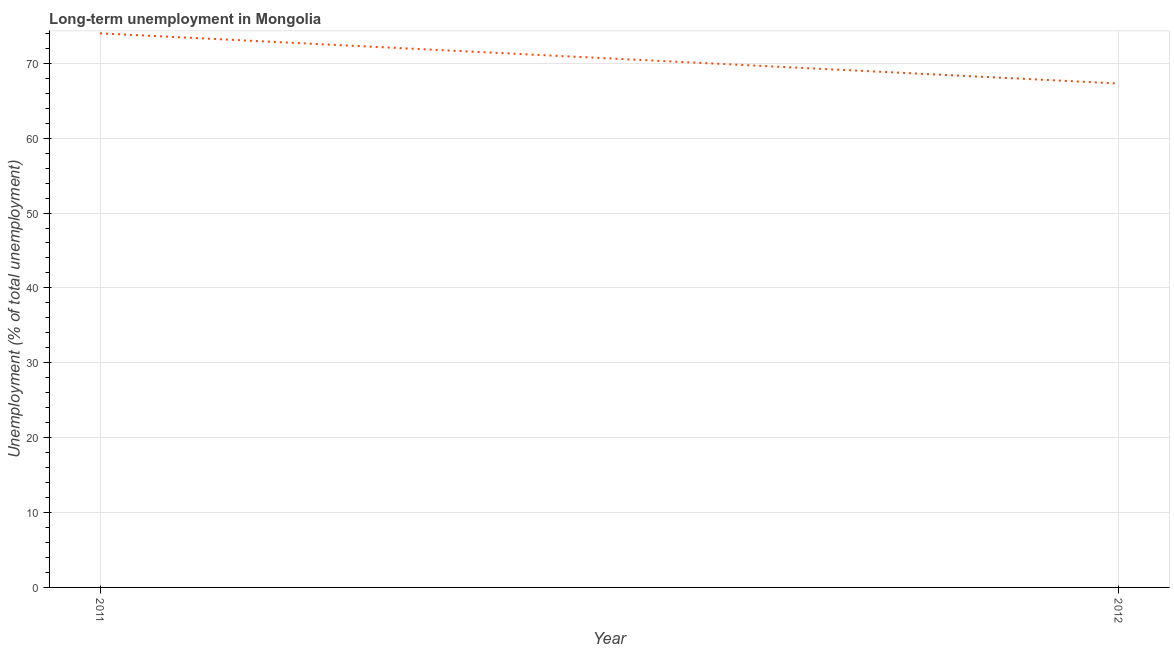What is the long-term unemployment in 2011?
Provide a short and direct response. 74. Across all years, what is the minimum long-term unemployment?
Your answer should be very brief. 67.3. In which year was the long-term unemployment maximum?
Provide a short and direct response. 2011. In which year was the long-term unemployment minimum?
Your answer should be very brief. 2012. What is the sum of the long-term unemployment?
Keep it short and to the point. 141.3. What is the difference between the long-term unemployment in 2011 and 2012?
Your answer should be very brief. 6.7. What is the average long-term unemployment per year?
Ensure brevity in your answer.  70.65. What is the median long-term unemployment?
Offer a terse response. 70.65. What is the ratio of the long-term unemployment in 2011 to that in 2012?
Keep it short and to the point. 1.1. In how many years, is the long-term unemployment greater than the average long-term unemployment taken over all years?
Give a very brief answer. 1. What is the difference between two consecutive major ticks on the Y-axis?
Your response must be concise. 10. What is the title of the graph?
Provide a succinct answer. Long-term unemployment in Mongolia. What is the label or title of the X-axis?
Offer a terse response. Year. What is the label or title of the Y-axis?
Ensure brevity in your answer.  Unemployment (% of total unemployment). What is the Unemployment (% of total unemployment) of 2011?
Keep it short and to the point. 74. What is the Unemployment (% of total unemployment) in 2012?
Give a very brief answer. 67.3. What is the ratio of the Unemployment (% of total unemployment) in 2011 to that in 2012?
Keep it short and to the point. 1.1. 